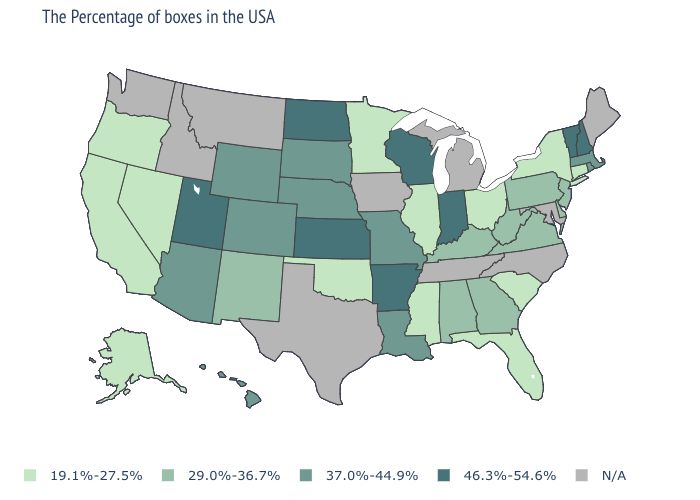Name the states that have a value in the range 46.3%-54.6%?
Give a very brief answer. New Hampshire, Vermont, Indiana, Wisconsin, Arkansas, Kansas, North Dakota, Utah. Name the states that have a value in the range 46.3%-54.6%?
Quick response, please. New Hampshire, Vermont, Indiana, Wisconsin, Arkansas, Kansas, North Dakota, Utah. Is the legend a continuous bar?
Give a very brief answer. No. What is the highest value in the USA?
Answer briefly. 46.3%-54.6%. What is the lowest value in the USA?
Answer briefly. 19.1%-27.5%. What is the value of Illinois?
Short answer required. 19.1%-27.5%. Does Utah have the highest value in the West?
Quick response, please. Yes. Name the states that have a value in the range 29.0%-36.7%?
Be succinct. New Jersey, Delaware, Pennsylvania, Virginia, West Virginia, Georgia, Kentucky, Alabama, New Mexico. Name the states that have a value in the range N/A?
Give a very brief answer. Maine, Maryland, North Carolina, Michigan, Tennessee, Iowa, Texas, Montana, Idaho, Washington. Does the first symbol in the legend represent the smallest category?
Short answer required. Yes. What is the lowest value in the Northeast?
Quick response, please. 19.1%-27.5%. What is the highest value in states that border Michigan?
Keep it brief. 46.3%-54.6%. Name the states that have a value in the range 29.0%-36.7%?
Give a very brief answer. New Jersey, Delaware, Pennsylvania, Virginia, West Virginia, Georgia, Kentucky, Alabama, New Mexico. Name the states that have a value in the range N/A?
Be succinct. Maine, Maryland, North Carolina, Michigan, Tennessee, Iowa, Texas, Montana, Idaho, Washington. Does the first symbol in the legend represent the smallest category?
Keep it brief. Yes. 